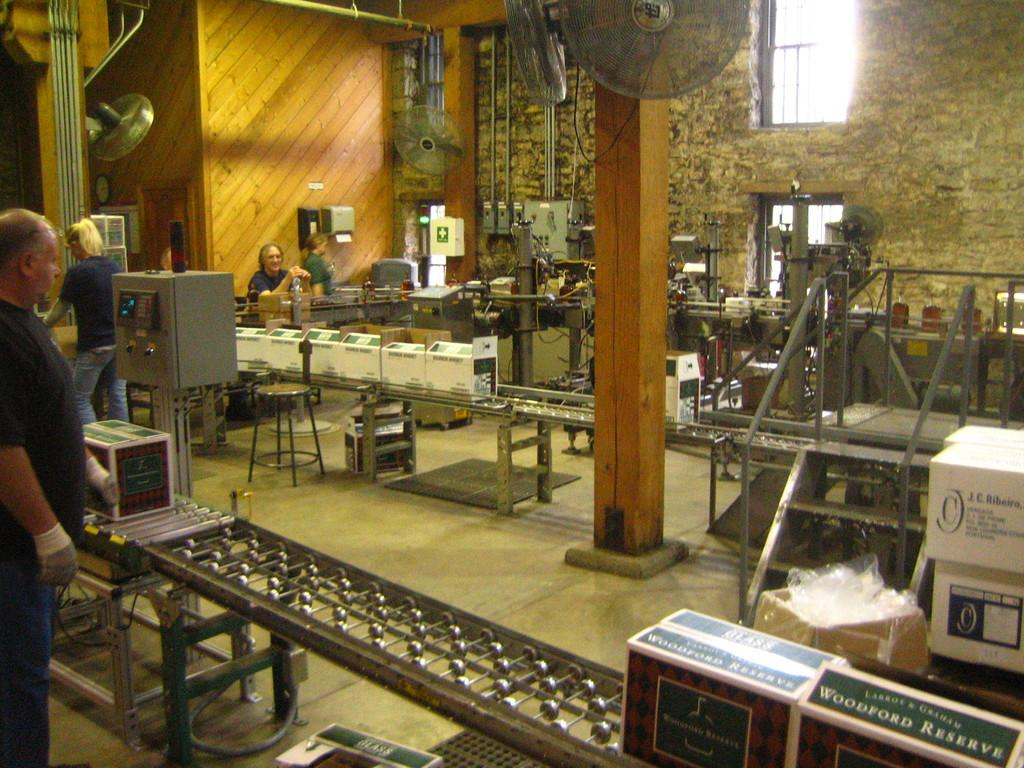<image>
Summarize the visual content of the image. Woodford Reserve boxes are on a conveyor belt. 